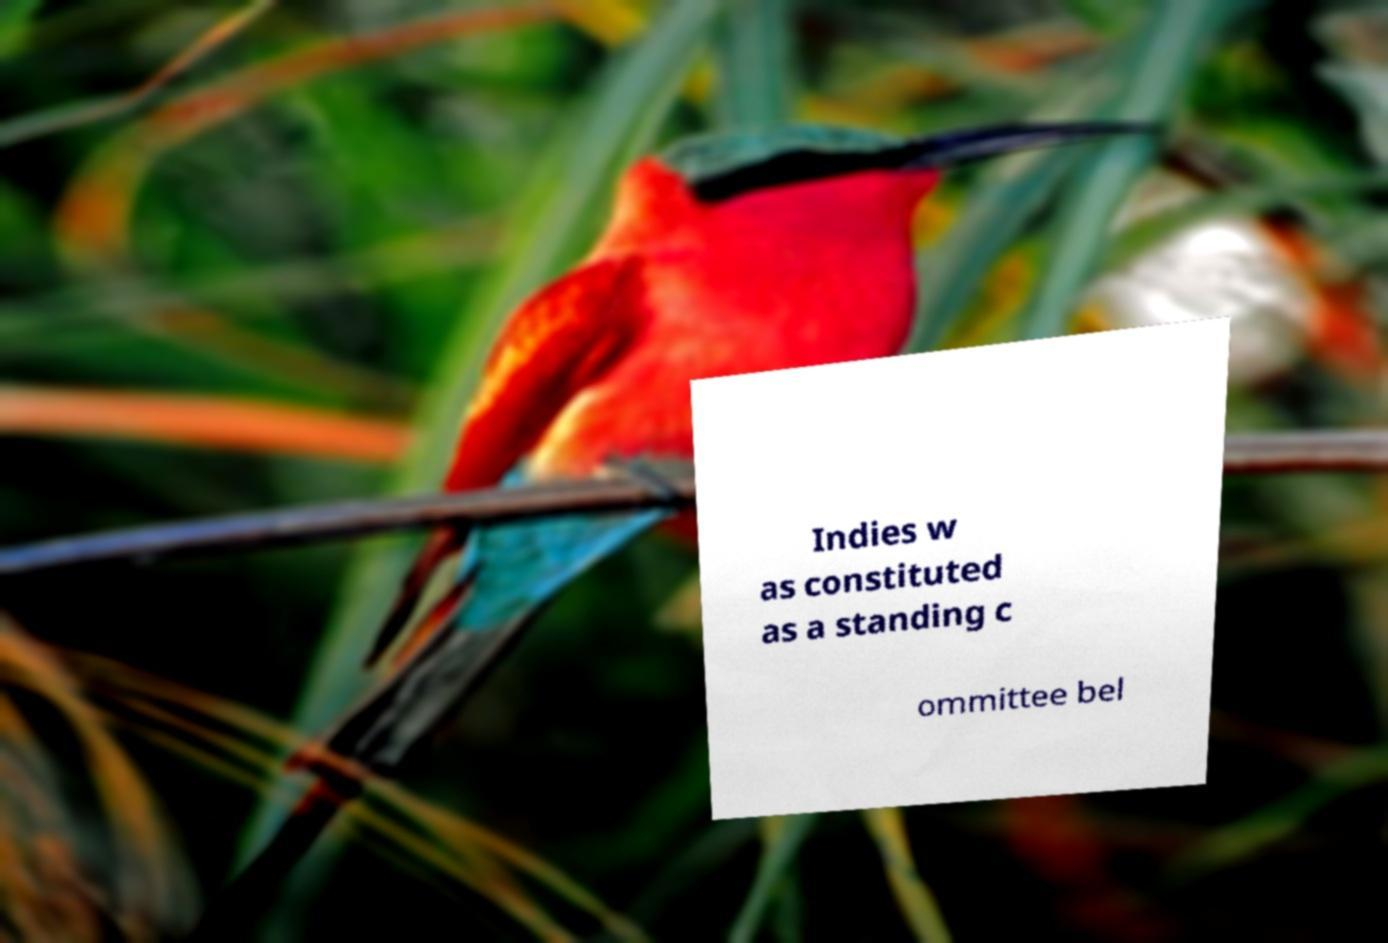Please read and relay the text visible in this image. What does it say? Indies w as constituted as a standing c ommittee bel 